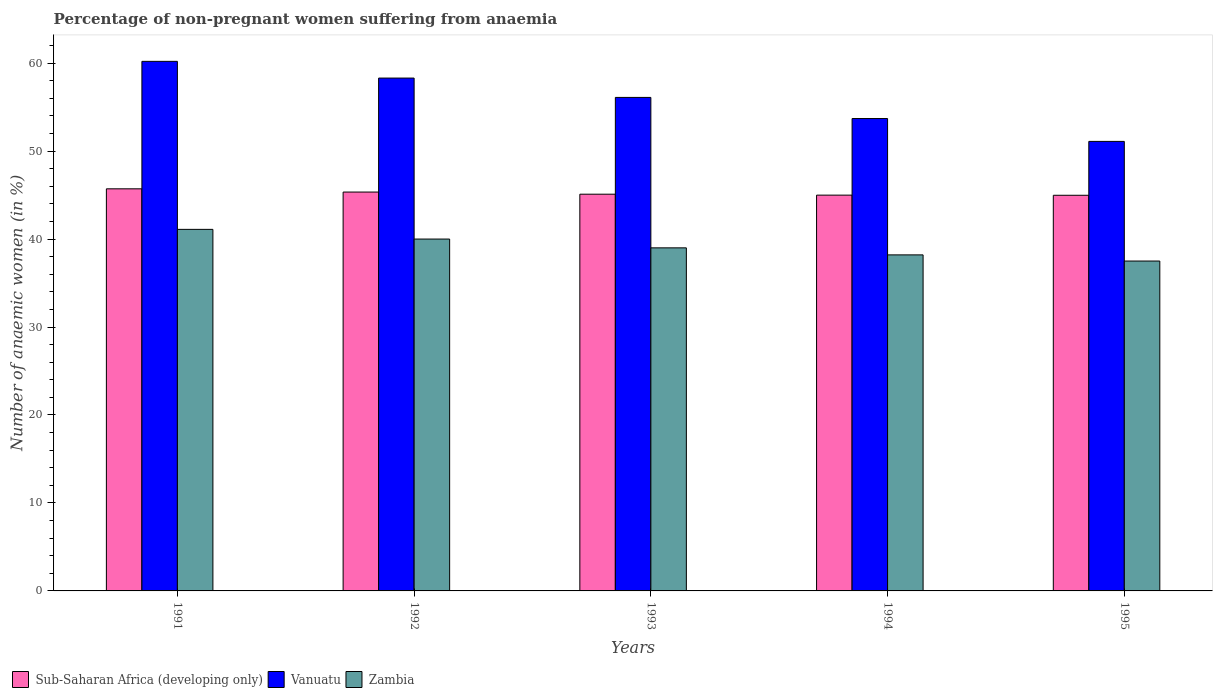How many different coloured bars are there?
Make the answer very short. 3. Are the number of bars per tick equal to the number of legend labels?
Offer a terse response. Yes. Are the number of bars on each tick of the X-axis equal?
Offer a terse response. Yes. How many bars are there on the 1st tick from the left?
Provide a succinct answer. 3. How many bars are there on the 4th tick from the right?
Keep it short and to the point. 3. In how many cases, is the number of bars for a given year not equal to the number of legend labels?
Your answer should be compact. 0. What is the percentage of non-pregnant women suffering from anaemia in Zambia in 1992?
Make the answer very short. 40. Across all years, what is the maximum percentage of non-pregnant women suffering from anaemia in Vanuatu?
Offer a very short reply. 60.2. Across all years, what is the minimum percentage of non-pregnant women suffering from anaemia in Sub-Saharan Africa (developing only)?
Offer a terse response. 44.98. What is the total percentage of non-pregnant women suffering from anaemia in Vanuatu in the graph?
Give a very brief answer. 279.4. What is the difference between the percentage of non-pregnant women suffering from anaemia in Sub-Saharan Africa (developing only) in 1992 and that in 1994?
Provide a succinct answer. 0.35. What is the difference between the percentage of non-pregnant women suffering from anaemia in Sub-Saharan Africa (developing only) in 1992 and the percentage of non-pregnant women suffering from anaemia in Zambia in 1995?
Your response must be concise. 7.84. What is the average percentage of non-pregnant women suffering from anaemia in Zambia per year?
Your response must be concise. 39.16. In the year 1994, what is the difference between the percentage of non-pregnant women suffering from anaemia in Zambia and percentage of non-pregnant women suffering from anaemia in Sub-Saharan Africa (developing only)?
Your response must be concise. -6.79. What is the ratio of the percentage of non-pregnant women suffering from anaemia in Sub-Saharan Africa (developing only) in 1991 to that in 1994?
Give a very brief answer. 1.02. Is the percentage of non-pregnant women suffering from anaemia in Sub-Saharan Africa (developing only) in 1993 less than that in 1994?
Provide a short and direct response. No. What is the difference between the highest and the second highest percentage of non-pregnant women suffering from anaemia in Sub-Saharan Africa (developing only)?
Offer a very short reply. 0.37. What is the difference between the highest and the lowest percentage of non-pregnant women suffering from anaemia in Sub-Saharan Africa (developing only)?
Your response must be concise. 0.73. What does the 1st bar from the left in 1995 represents?
Offer a very short reply. Sub-Saharan Africa (developing only). What does the 3rd bar from the right in 1991 represents?
Offer a very short reply. Sub-Saharan Africa (developing only). Is it the case that in every year, the sum of the percentage of non-pregnant women suffering from anaemia in Sub-Saharan Africa (developing only) and percentage of non-pregnant women suffering from anaemia in Vanuatu is greater than the percentage of non-pregnant women suffering from anaemia in Zambia?
Keep it short and to the point. Yes. How many bars are there?
Keep it short and to the point. 15. What is the difference between two consecutive major ticks on the Y-axis?
Your answer should be very brief. 10. Where does the legend appear in the graph?
Your answer should be very brief. Bottom left. How are the legend labels stacked?
Keep it short and to the point. Horizontal. What is the title of the graph?
Your answer should be compact. Percentage of non-pregnant women suffering from anaemia. Does "Macao" appear as one of the legend labels in the graph?
Give a very brief answer. No. What is the label or title of the Y-axis?
Your answer should be compact. Number of anaemic women (in %). What is the Number of anaemic women (in %) of Sub-Saharan Africa (developing only) in 1991?
Ensure brevity in your answer.  45.71. What is the Number of anaemic women (in %) of Vanuatu in 1991?
Your answer should be very brief. 60.2. What is the Number of anaemic women (in %) of Zambia in 1991?
Your response must be concise. 41.1. What is the Number of anaemic women (in %) in Sub-Saharan Africa (developing only) in 1992?
Ensure brevity in your answer.  45.34. What is the Number of anaemic women (in %) in Vanuatu in 1992?
Offer a very short reply. 58.3. What is the Number of anaemic women (in %) in Sub-Saharan Africa (developing only) in 1993?
Your answer should be very brief. 45.1. What is the Number of anaemic women (in %) of Vanuatu in 1993?
Provide a succinct answer. 56.1. What is the Number of anaemic women (in %) of Zambia in 1993?
Offer a very short reply. 39. What is the Number of anaemic women (in %) in Sub-Saharan Africa (developing only) in 1994?
Offer a very short reply. 44.99. What is the Number of anaemic women (in %) in Vanuatu in 1994?
Offer a very short reply. 53.7. What is the Number of anaemic women (in %) in Zambia in 1994?
Keep it short and to the point. 38.2. What is the Number of anaemic women (in %) in Sub-Saharan Africa (developing only) in 1995?
Provide a short and direct response. 44.98. What is the Number of anaemic women (in %) in Vanuatu in 1995?
Your answer should be compact. 51.1. What is the Number of anaemic women (in %) in Zambia in 1995?
Give a very brief answer. 37.5. Across all years, what is the maximum Number of anaemic women (in %) of Sub-Saharan Africa (developing only)?
Keep it short and to the point. 45.71. Across all years, what is the maximum Number of anaemic women (in %) in Vanuatu?
Provide a short and direct response. 60.2. Across all years, what is the maximum Number of anaemic women (in %) in Zambia?
Offer a very short reply. 41.1. Across all years, what is the minimum Number of anaemic women (in %) in Sub-Saharan Africa (developing only)?
Provide a short and direct response. 44.98. Across all years, what is the minimum Number of anaemic women (in %) in Vanuatu?
Make the answer very short. 51.1. Across all years, what is the minimum Number of anaemic women (in %) in Zambia?
Give a very brief answer. 37.5. What is the total Number of anaemic women (in %) of Sub-Saharan Africa (developing only) in the graph?
Keep it short and to the point. 226.12. What is the total Number of anaemic women (in %) in Vanuatu in the graph?
Provide a succinct answer. 279.4. What is the total Number of anaemic women (in %) in Zambia in the graph?
Your answer should be very brief. 195.8. What is the difference between the Number of anaemic women (in %) of Sub-Saharan Africa (developing only) in 1991 and that in 1992?
Provide a short and direct response. 0.37. What is the difference between the Number of anaemic women (in %) of Sub-Saharan Africa (developing only) in 1991 and that in 1993?
Give a very brief answer. 0.61. What is the difference between the Number of anaemic women (in %) in Vanuatu in 1991 and that in 1993?
Ensure brevity in your answer.  4.1. What is the difference between the Number of anaemic women (in %) in Sub-Saharan Africa (developing only) in 1991 and that in 1994?
Make the answer very short. 0.72. What is the difference between the Number of anaemic women (in %) of Vanuatu in 1991 and that in 1994?
Provide a short and direct response. 6.5. What is the difference between the Number of anaemic women (in %) of Sub-Saharan Africa (developing only) in 1991 and that in 1995?
Make the answer very short. 0.73. What is the difference between the Number of anaemic women (in %) of Sub-Saharan Africa (developing only) in 1992 and that in 1993?
Your answer should be very brief. 0.24. What is the difference between the Number of anaemic women (in %) of Vanuatu in 1992 and that in 1993?
Provide a succinct answer. 2.2. What is the difference between the Number of anaemic women (in %) in Sub-Saharan Africa (developing only) in 1992 and that in 1994?
Your answer should be very brief. 0.35. What is the difference between the Number of anaemic women (in %) of Sub-Saharan Africa (developing only) in 1992 and that in 1995?
Provide a short and direct response. 0.36. What is the difference between the Number of anaemic women (in %) in Vanuatu in 1992 and that in 1995?
Provide a succinct answer. 7.2. What is the difference between the Number of anaemic women (in %) in Zambia in 1992 and that in 1995?
Offer a very short reply. 2.5. What is the difference between the Number of anaemic women (in %) in Sub-Saharan Africa (developing only) in 1993 and that in 1994?
Offer a terse response. 0.11. What is the difference between the Number of anaemic women (in %) of Sub-Saharan Africa (developing only) in 1993 and that in 1995?
Offer a very short reply. 0.12. What is the difference between the Number of anaemic women (in %) in Vanuatu in 1993 and that in 1995?
Give a very brief answer. 5. What is the difference between the Number of anaemic women (in %) in Zambia in 1993 and that in 1995?
Offer a very short reply. 1.5. What is the difference between the Number of anaemic women (in %) of Sub-Saharan Africa (developing only) in 1994 and that in 1995?
Your answer should be very brief. 0.01. What is the difference between the Number of anaemic women (in %) of Vanuatu in 1994 and that in 1995?
Provide a succinct answer. 2.6. What is the difference between the Number of anaemic women (in %) of Sub-Saharan Africa (developing only) in 1991 and the Number of anaemic women (in %) of Vanuatu in 1992?
Your answer should be very brief. -12.59. What is the difference between the Number of anaemic women (in %) of Sub-Saharan Africa (developing only) in 1991 and the Number of anaemic women (in %) of Zambia in 1992?
Provide a short and direct response. 5.71. What is the difference between the Number of anaemic women (in %) in Vanuatu in 1991 and the Number of anaemic women (in %) in Zambia in 1992?
Offer a very short reply. 20.2. What is the difference between the Number of anaemic women (in %) of Sub-Saharan Africa (developing only) in 1991 and the Number of anaemic women (in %) of Vanuatu in 1993?
Make the answer very short. -10.39. What is the difference between the Number of anaemic women (in %) in Sub-Saharan Africa (developing only) in 1991 and the Number of anaemic women (in %) in Zambia in 1993?
Make the answer very short. 6.71. What is the difference between the Number of anaemic women (in %) of Vanuatu in 1991 and the Number of anaemic women (in %) of Zambia in 1993?
Provide a short and direct response. 21.2. What is the difference between the Number of anaemic women (in %) of Sub-Saharan Africa (developing only) in 1991 and the Number of anaemic women (in %) of Vanuatu in 1994?
Ensure brevity in your answer.  -7.99. What is the difference between the Number of anaemic women (in %) of Sub-Saharan Africa (developing only) in 1991 and the Number of anaemic women (in %) of Zambia in 1994?
Keep it short and to the point. 7.51. What is the difference between the Number of anaemic women (in %) in Sub-Saharan Africa (developing only) in 1991 and the Number of anaemic women (in %) in Vanuatu in 1995?
Your response must be concise. -5.39. What is the difference between the Number of anaemic women (in %) in Sub-Saharan Africa (developing only) in 1991 and the Number of anaemic women (in %) in Zambia in 1995?
Offer a very short reply. 8.21. What is the difference between the Number of anaemic women (in %) of Vanuatu in 1991 and the Number of anaemic women (in %) of Zambia in 1995?
Offer a terse response. 22.7. What is the difference between the Number of anaemic women (in %) of Sub-Saharan Africa (developing only) in 1992 and the Number of anaemic women (in %) of Vanuatu in 1993?
Ensure brevity in your answer.  -10.76. What is the difference between the Number of anaemic women (in %) of Sub-Saharan Africa (developing only) in 1992 and the Number of anaemic women (in %) of Zambia in 1993?
Keep it short and to the point. 6.34. What is the difference between the Number of anaemic women (in %) of Vanuatu in 1992 and the Number of anaemic women (in %) of Zambia in 1993?
Your answer should be compact. 19.3. What is the difference between the Number of anaemic women (in %) in Sub-Saharan Africa (developing only) in 1992 and the Number of anaemic women (in %) in Vanuatu in 1994?
Offer a terse response. -8.36. What is the difference between the Number of anaemic women (in %) of Sub-Saharan Africa (developing only) in 1992 and the Number of anaemic women (in %) of Zambia in 1994?
Your answer should be compact. 7.14. What is the difference between the Number of anaemic women (in %) in Vanuatu in 1992 and the Number of anaemic women (in %) in Zambia in 1994?
Offer a very short reply. 20.1. What is the difference between the Number of anaemic women (in %) of Sub-Saharan Africa (developing only) in 1992 and the Number of anaemic women (in %) of Vanuatu in 1995?
Provide a short and direct response. -5.76. What is the difference between the Number of anaemic women (in %) in Sub-Saharan Africa (developing only) in 1992 and the Number of anaemic women (in %) in Zambia in 1995?
Make the answer very short. 7.84. What is the difference between the Number of anaemic women (in %) of Vanuatu in 1992 and the Number of anaemic women (in %) of Zambia in 1995?
Keep it short and to the point. 20.8. What is the difference between the Number of anaemic women (in %) in Sub-Saharan Africa (developing only) in 1993 and the Number of anaemic women (in %) in Vanuatu in 1994?
Offer a very short reply. -8.6. What is the difference between the Number of anaemic women (in %) in Sub-Saharan Africa (developing only) in 1993 and the Number of anaemic women (in %) in Zambia in 1994?
Ensure brevity in your answer.  6.9. What is the difference between the Number of anaemic women (in %) in Sub-Saharan Africa (developing only) in 1993 and the Number of anaemic women (in %) in Vanuatu in 1995?
Make the answer very short. -6. What is the difference between the Number of anaemic women (in %) of Sub-Saharan Africa (developing only) in 1993 and the Number of anaemic women (in %) of Zambia in 1995?
Ensure brevity in your answer.  7.6. What is the difference between the Number of anaemic women (in %) of Vanuatu in 1993 and the Number of anaemic women (in %) of Zambia in 1995?
Offer a very short reply. 18.6. What is the difference between the Number of anaemic women (in %) in Sub-Saharan Africa (developing only) in 1994 and the Number of anaemic women (in %) in Vanuatu in 1995?
Keep it short and to the point. -6.11. What is the difference between the Number of anaemic women (in %) of Sub-Saharan Africa (developing only) in 1994 and the Number of anaemic women (in %) of Zambia in 1995?
Your response must be concise. 7.49. What is the average Number of anaemic women (in %) in Sub-Saharan Africa (developing only) per year?
Offer a terse response. 45.22. What is the average Number of anaemic women (in %) of Vanuatu per year?
Ensure brevity in your answer.  55.88. What is the average Number of anaemic women (in %) in Zambia per year?
Offer a terse response. 39.16. In the year 1991, what is the difference between the Number of anaemic women (in %) in Sub-Saharan Africa (developing only) and Number of anaemic women (in %) in Vanuatu?
Make the answer very short. -14.49. In the year 1991, what is the difference between the Number of anaemic women (in %) of Sub-Saharan Africa (developing only) and Number of anaemic women (in %) of Zambia?
Provide a short and direct response. 4.61. In the year 1991, what is the difference between the Number of anaemic women (in %) in Vanuatu and Number of anaemic women (in %) in Zambia?
Ensure brevity in your answer.  19.1. In the year 1992, what is the difference between the Number of anaemic women (in %) in Sub-Saharan Africa (developing only) and Number of anaemic women (in %) in Vanuatu?
Ensure brevity in your answer.  -12.96. In the year 1992, what is the difference between the Number of anaemic women (in %) of Sub-Saharan Africa (developing only) and Number of anaemic women (in %) of Zambia?
Offer a very short reply. 5.34. In the year 1992, what is the difference between the Number of anaemic women (in %) in Vanuatu and Number of anaemic women (in %) in Zambia?
Your answer should be compact. 18.3. In the year 1993, what is the difference between the Number of anaemic women (in %) of Sub-Saharan Africa (developing only) and Number of anaemic women (in %) of Vanuatu?
Offer a terse response. -11. In the year 1993, what is the difference between the Number of anaemic women (in %) in Sub-Saharan Africa (developing only) and Number of anaemic women (in %) in Zambia?
Ensure brevity in your answer.  6.1. In the year 1993, what is the difference between the Number of anaemic women (in %) of Vanuatu and Number of anaemic women (in %) of Zambia?
Ensure brevity in your answer.  17.1. In the year 1994, what is the difference between the Number of anaemic women (in %) of Sub-Saharan Africa (developing only) and Number of anaemic women (in %) of Vanuatu?
Give a very brief answer. -8.71. In the year 1994, what is the difference between the Number of anaemic women (in %) of Sub-Saharan Africa (developing only) and Number of anaemic women (in %) of Zambia?
Provide a short and direct response. 6.79. In the year 1995, what is the difference between the Number of anaemic women (in %) of Sub-Saharan Africa (developing only) and Number of anaemic women (in %) of Vanuatu?
Offer a terse response. -6.12. In the year 1995, what is the difference between the Number of anaemic women (in %) of Sub-Saharan Africa (developing only) and Number of anaemic women (in %) of Zambia?
Offer a very short reply. 7.48. What is the ratio of the Number of anaemic women (in %) in Sub-Saharan Africa (developing only) in 1991 to that in 1992?
Your response must be concise. 1.01. What is the ratio of the Number of anaemic women (in %) in Vanuatu in 1991 to that in 1992?
Make the answer very short. 1.03. What is the ratio of the Number of anaemic women (in %) in Zambia in 1991 to that in 1992?
Keep it short and to the point. 1.03. What is the ratio of the Number of anaemic women (in %) of Sub-Saharan Africa (developing only) in 1991 to that in 1993?
Your answer should be compact. 1.01. What is the ratio of the Number of anaemic women (in %) of Vanuatu in 1991 to that in 1993?
Make the answer very short. 1.07. What is the ratio of the Number of anaemic women (in %) in Zambia in 1991 to that in 1993?
Offer a terse response. 1.05. What is the ratio of the Number of anaemic women (in %) in Vanuatu in 1991 to that in 1994?
Your response must be concise. 1.12. What is the ratio of the Number of anaemic women (in %) of Zambia in 1991 to that in 1994?
Keep it short and to the point. 1.08. What is the ratio of the Number of anaemic women (in %) of Sub-Saharan Africa (developing only) in 1991 to that in 1995?
Offer a terse response. 1.02. What is the ratio of the Number of anaemic women (in %) in Vanuatu in 1991 to that in 1995?
Offer a very short reply. 1.18. What is the ratio of the Number of anaemic women (in %) in Zambia in 1991 to that in 1995?
Your response must be concise. 1.1. What is the ratio of the Number of anaemic women (in %) in Sub-Saharan Africa (developing only) in 1992 to that in 1993?
Your response must be concise. 1.01. What is the ratio of the Number of anaemic women (in %) in Vanuatu in 1992 to that in 1993?
Make the answer very short. 1.04. What is the ratio of the Number of anaemic women (in %) of Zambia in 1992 to that in 1993?
Offer a very short reply. 1.03. What is the ratio of the Number of anaemic women (in %) of Sub-Saharan Africa (developing only) in 1992 to that in 1994?
Provide a short and direct response. 1.01. What is the ratio of the Number of anaemic women (in %) of Vanuatu in 1992 to that in 1994?
Your answer should be very brief. 1.09. What is the ratio of the Number of anaemic women (in %) of Zambia in 1992 to that in 1994?
Offer a very short reply. 1.05. What is the ratio of the Number of anaemic women (in %) in Sub-Saharan Africa (developing only) in 1992 to that in 1995?
Offer a terse response. 1.01. What is the ratio of the Number of anaemic women (in %) in Vanuatu in 1992 to that in 1995?
Your answer should be compact. 1.14. What is the ratio of the Number of anaemic women (in %) in Zambia in 1992 to that in 1995?
Provide a succinct answer. 1.07. What is the ratio of the Number of anaemic women (in %) in Sub-Saharan Africa (developing only) in 1993 to that in 1994?
Provide a succinct answer. 1. What is the ratio of the Number of anaemic women (in %) of Vanuatu in 1993 to that in 1994?
Provide a succinct answer. 1.04. What is the ratio of the Number of anaemic women (in %) of Zambia in 1993 to that in 1994?
Provide a short and direct response. 1.02. What is the ratio of the Number of anaemic women (in %) of Sub-Saharan Africa (developing only) in 1993 to that in 1995?
Give a very brief answer. 1. What is the ratio of the Number of anaemic women (in %) of Vanuatu in 1993 to that in 1995?
Make the answer very short. 1.1. What is the ratio of the Number of anaemic women (in %) of Zambia in 1993 to that in 1995?
Ensure brevity in your answer.  1.04. What is the ratio of the Number of anaemic women (in %) in Sub-Saharan Africa (developing only) in 1994 to that in 1995?
Offer a terse response. 1. What is the ratio of the Number of anaemic women (in %) in Vanuatu in 1994 to that in 1995?
Your answer should be compact. 1.05. What is the ratio of the Number of anaemic women (in %) of Zambia in 1994 to that in 1995?
Provide a short and direct response. 1.02. What is the difference between the highest and the second highest Number of anaemic women (in %) in Sub-Saharan Africa (developing only)?
Your answer should be very brief. 0.37. What is the difference between the highest and the second highest Number of anaemic women (in %) in Zambia?
Make the answer very short. 1.1. What is the difference between the highest and the lowest Number of anaemic women (in %) in Sub-Saharan Africa (developing only)?
Your answer should be compact. 0.73. 